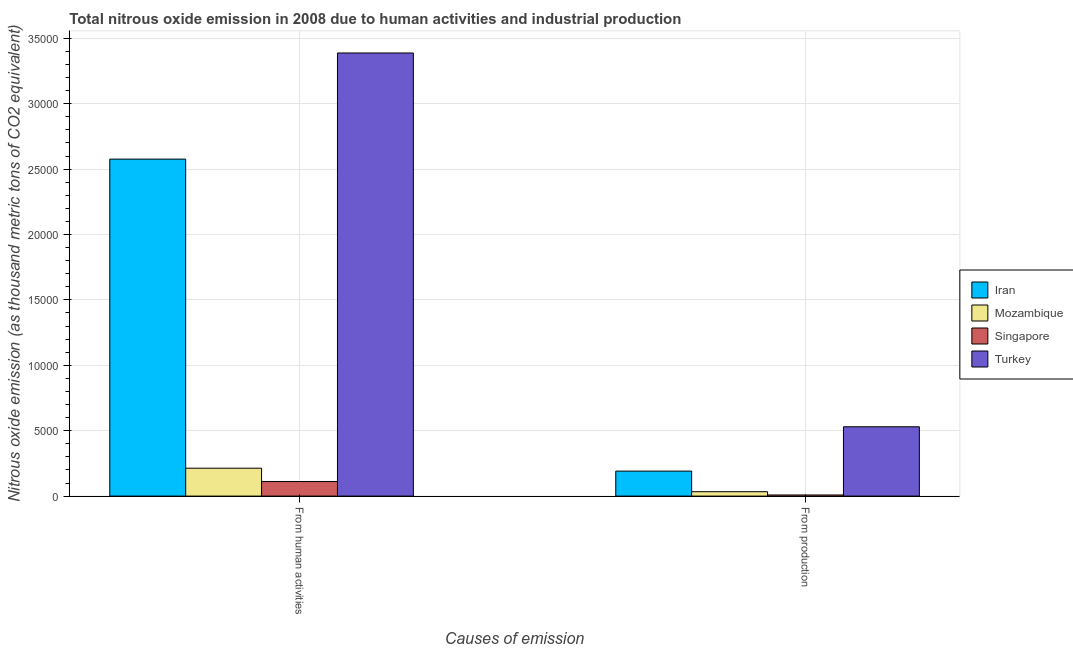How many groups of bars are there?
Your response must be concise. 2. Are the number of bars on each tick of the X-axis equal?
Ensure brevity in your answer.  Yes. How many bars are there on the 2nd tick from the left?
Offer a very short reply. 4. How many bars are there on the 2nd tick from the right?
Your answer should be very brief. 4. What is the label of the 1st group of bars from the left?
Offer a terse response. From human activities. What is the amount of emissions from human activities in Turkey?
Provide a short and direct response. 3.39e+04. Across all countries, what is the maximum amount of emissions generated from industries?
Give a very brief answer. 5300.3. Across all countries, what is the minimum amount of emissions from human activities?
Your response must be concise. 1113.5. In which country was the amount of emissions generated from industries maximum?
Ensure brevity in your answer.  Turkey. In which country was the amount of emissions from human activities minimum?
Offer a very short reply. Singapore. What is the total amount of emissions from human activities in the graph?
Make the answer very short. 6.29e+04. What is the difference between the amount of emissions from human activities in Singapore and that in Turkey?
Make the answer very short. -3.28e+04. What is the difference between the amount of emissions generated from industries in Turkey and the amount of emissions from human activities in Mozambique?
Ensure brevity in your answer.  3166.8. What is the average amount of emissions from human activities per country?
Offer a terse response. 1.57e+04. What is the difference between the amount of emissions generated from industries and amount of emissions from human activities in Singapore?
Your response must be concise. -1026.6. What is the ratio of the amount of emissions generated from industries in Mozambique to that in Iran?
Provide a short and direct response. 0.18. Is the amount of emissions generated from industries in Mozambique less than that in Singapore?
Your answer should be very brief. No. In how many countries, is the amount of emissions generated from industries greater than the average amount of emissions generated from industries taken over all countries?
Offer a terse response. 2. What does the 3rd bar from the left in From production represents?
Your response must be concise. Singapore. What does the 4th bar from the right in From human activities represents?
Your answer should be compact. Iran. How many bars are there?
Your answer should be compact. 8. Are the values on the major ticks of Y-axis written in scientific E-notation?
Keep it short and to the point. No. Does the graph contain any zero values?
Your answer should be very brief. No. What is the title of the graph?
Your response must be concise. Total nitrous oxide emission in 2008 due to human activities and industrial production. What is the label or title of the X-axis?
Give a very brief answer. Causes of emission. What is the label or title of the Y-axis?
Your answer should be very brief. Nitrous oxide emission (as thousand metric tons of CO2 equivalent). What is the Nitrous oxide emission (as thousand metric tons of CO2 equivalent) in Iran in From human activities?
Your answer should be very brief. 2.58e+04. What is the Nitrous oxide emission (as thousand metric tons of CO2 equivalent) in Mozambique in From human activities?
Provide a short and direct response. 2133.5. What is the Nitrous oxide emission (as thousand metric tons of CO2 equivalent) of Singapore in From human activities?
Your answer should be very brief. 1113.5. What is the Nitrous oxide emission (as thousand metric tons of CO2 equivalent) of Turkey in From human activities?
Your answer should be very brief. 3.39e+04. What is the Nitrous oxide emission (as thousand metric tons of CO2 equivalent) in Iran in From production?
Keep it short and to the point. 1911.5. What is the Nitrous oxide emission (as thousand metric tons of CO2 equivalent) in Mozambique in From production?
Keep it short and to the point. 336.3. What is the Nitrous oxide emission (as thousand metric tons of CO2 equivalent) in Singapore in From production?
Give a very brief answer. 86.9. What is the Nitrous oxide emission (as thousand metric tons of CO2 equivalent) of Turkey in From production?
Keep it short and to the point. 5300.3. Across all Causes of emission, what is the maximum Nitrous oxide emission (as thousand metric tons of CO2 equivalent) of Iran?
Keep it short and to the point. 2.58e+04. Across all Causes of emission, what is the maximum Nitrous oxide emission (as thousand metric tons of CO2 equivalent) in Mozambique?
Your answer should be compact. 2133.5. Across all Causes of emission, what is the maximum Nitrous oxide emission (as thousand metric tons of CO2 equivalent) of Singapore?
Keep it short and to the point. 1113.5. Across all Causes of emission, what is the maximum Nitrous oxide emission (as thousand metric tons of CO2 equivalent) in Turkey?
Your response must be concise. 3.39e+04. Across all Causes of emission, what is the minimum Nitrous oxide emission (as thousand metric tons of CO2 equivalent) of Iran?
Ensure brevity in your answer.  1911.5. Across all Causes of emission, what is the minimum Nitrous oxide emission (as thousand metric tons of CO2 equivalent) in Mozambique?
Your answer should be very brief. 336.3. Across all Causes of emission, what is the minimum Nitrous oxide emission (as thousand metric tons of CO2 equivalent) of Singapore?
Your answer should be compact. 86.9. Across all Causes of emission, what is the minimum Nitrous oxide emission (as thousand metric tons of CO2 equivalent) of Turkey?
Keep it short and to the point. 5300.3. What is the total Nitrous oxide emission (as thousand metric tons of CO2 equivalent) in Iran in the graph?
Make the answer very short. 2.77e+04. What is the total Nitrous oxide emission (as thousand metric tons of CO2 equivalent) of Mozambique in the graph?
Provide a short and direct response. 2469.8. What is the total Nitrous oxide emission (as thousand metric tons of CO2 equivalent) of Singapore in the graph?
Your response must be concise. 1200.4. What is the total Nitrous oxide emission (as thousand metric tons of CO2 equivalent) in Turkey in the graph?
Provide a succinct answer. 3.92e+04. What is the difference between the Nitrous oxide emission (as thousand metric tons of CO2 equivalent) in Iran in From human activities and that in From production?
Make the answer very short. 2.39e+04. What is the difference between the Nitrous oxide emission (as thousand metric tons of CO2 equivalent) in Mozambique in From human activities and that in From production?
Give a very brief answer. 1797.2. What is the difference between the Nitrous oxide emission (as thousand metric tons of CO2 equivalent) in Singapore in From human activities and that in From production?
Provide a short and direct response. 1026.6. What is the difference between the Nitrous oxide emission (as thousand metric tons of CO2 equivalent) of Turkey in From human activities and that in From production?
Provide a short and direct response. 2.86e+04. What is the difference between the Nitrous oxide emission (as thousand metric tons of CO2 equivalent) of Iran in From human activities and the Nitrous oxide emission (as thousand metric tons of CO2 equivalent) of Mozambique in From production?
Give a very brief answer. 2.54e+04. What is the difference between the Nitrous oxide emission (as thousand metric tons of CO2 equivalent) of Iran in From human activities and the Nitrous oxide emission (as thousand metric tons of CO2 equivalent) of Singapore in From production?
Keep it short and to the point. 2.57e+04. What is the difference between the Nitrous oxide emission (as thousand metric tons of CO2 equivalent) of Iran in From human activities and the Nitrous oxide emission (as thousand metric tons of CO2 equivalent) of Turkey in From production?
Your answer should be very brief. 2.05e+04. What is the difference between the Nitrous oxide emission (as thousand metric tons of CO2 equivalent) in Mozambique in From human activities and the Nitrous oxide emission (as thousand metric tons of CO2 equivalent) in Singapore in From production?
Keep it short and to the point. 2046.6. What is the difference between the Nitrous oxide emission (as thousand metric tons of CO2 equivalent) in Mozambique in From human activities and the Nitrous oxide emission (as thousand metric tons of CO2 equivalent) in Turkey in From production?
Provide a succinct answer. -3166.8. What is the difference between the Nitrous oxide emission (as thousand metric tons of CO2 equivalent) in Singapore in From human activities and the Nitrous oxide emission (as thousand metric tons of CO2 equivalent) in Turkey in From production?
Provide a short and direct response. -4186.8. What is the average Nitrous oxide emission (as thousand metric tons of CO2 equivalent) in Iran per Causes of emission?
Offer a terse response. 1.38e+04. What is the average Nitrous oxide emission (as thousand metric tons of CO2 equivalent) in Mozambique per Causes of emission?
Make the answer very short. 1234.9. What is the average Nitrous oxide emission (as thousand metric tons of CO2 equivalent) in Singapore per Causes of emission?
Keep it short and to the point. 600.2. What is the average Nitrous oxide emission (as thousand metric tons of CO2 equivalent) in Turkey per Causes of emission?
Ensure brevity in your answer.  1.96e+04. What is the difference between the Nitrous oxide emission (as thousand metric tons of CO2 equivalent) in Iran and Nitrous oxide emission (as thousand metric tons of CO2 equivalent) in Mozambique in From human activities?
Provide a short and direct response. 2.36e+04. What is the difference between the Nitrous oxide emission (as thousand metric tons of CO2 equivalent) of Iran and Nitrous oxide emission (as thousand metric tons of CO2 equivalent) of Singapore in From human activities?
Your response must be concise. 2.46e+04. What is the difference between the Nitrous oxide emission (as thousand metric tons of CO2 equivalent) of Iran and Nitrous oxide emission (as thousand metric tons of CO2 equivalent) of Turkey in From human activities?
Keep it short and to the point. -8114.9. What is the difference between the Nitrous oxide emission (as thousand metric tons of CO2 equivalent) in Mozambique and Nitrous oxide emission (as thousand metric tons of CO2 equivalent) in Singapore in From human activities?
Your answer should be very brief. 1020. What is the difference between the Nitrous oxide emission (as thousand metric tons of CO2 equivalent) in Mozambique and Nitrous oxide emission (as thousand metric tons of CO2 equivalent) in Turkey in From human activities?
Your response must be concise. -3.17e+04. What is the difference between the Nitrous oxide emission (as thousand metric tons of CO2 equivalent) of Singapore and Nitrous oxide emission (as thousand metric tons of CO2 equivalent) of Turkey in From human activities?
Keep it short and to the point. -3.28e+04. What is the difference between the Nitrous oxide emission (as thousand metric tons of CO2 equivalent) of Iran and Nitrous oxide emission (as thousand metric tons of CO2 equivalent) of Mozambique in From production?
Give a very brief answer. 1575.2. What is the difference between the Nitrous oxide emission (as thousand metric tons of CO2 equivalent) of Iran and Nitrous oxide emission (as thousand metric tons of CO2 equivalent) of Singapore in From production?
Provide a short and direct response. 1824.6. What is the difference between the Nitrous oxide emission (as thousand metric tons of CO2 equivalent) in Iran and Nitrous oxide emission (as thousand metric tons of CO2 equivalent) in Turkey in From production?
Keep it short and to the point. -3388.8. What is the difference between the Nitrous oxide emission (as thousand metric tons of CO2 equivalent) of Mozambique and Nitrous oxide emission (as thousand metric tons of CO2 equivalent) of Singapore in From production?
Ensure brevity in your answer.  249.4. What is the difference between the Nitrous oxide emission (as thousand metric tons of CO2 equivalent) in Mozambique and Nitrous oxide emission (as thousand metric tons of CO2 equivalent) in Turkey in From production?
Keep it short and to the point. -4964. What is the difference between the Nitrous oxide emission (as thousand metric tons of CO2 equivalent) of Singapore and Nitrous oxide emission (as thousand metric tons of CO2 equivalent) of Turkey in From production?
Your answer should be compact. -5213.4. What is the ratio of the Nitrous oxide emission (as thousand metric tons of CO2 equivalent) of Iran in From human activities to that in From production?
Ensure brevity in your answer.  13.48. What is the ratio of the Nitrous oxide emission (as thousand metric tons of CO2 equivalent) of Mozambique in From human activities to that in From production?
Give a very brief answer. 6.34. What is the ratio of the Nitrous oxide emission (as thousand metric tons of CO2 equivalent) of Singapore in From human activities to that in From production?
Give a very brief answer. 12.81. What is the ratio of the Nitrous oxide emission (as thousand metric tons of CO2 equivalent) in Turkey in From human activities to that in From production?
Provide a short and direct response. 6.39. What is the difference between the highest and the second highest Nitrous oxide emission (as thousand metric tons of CO2 equivalent) in Iran?
Ensure brevity in your answer.  2.39e+04. What is the difference between the highest and the second highest Nitrous oxide emission (as thousand metric tons of CO2 equivalent) of Mozambique?
Your answer should be very brief. 1797.2. What is the difference between the highest and the second highest Nitrous oxide emission (as thousand metric tons of CO2 equivalent) in Singapore?
Give a very brief answer. 1026.6. What is the difference between the highest and the second highest Nitrous oxide emission (as thousand metric tons of CO2 equivalent) of Turkey?
Provide a short and direct response. 2.86e+04. What is the difference between the highest and the lowest Nitrous oxide emission (as thousand metric tons of CO2 equivalent) in Iran?
Make the answer very short. 2.39e+04. What is the difference between the highest and the lowest Nitrous oxide emission (as thousand metric tons of CO2 equivalent) of Mozambique?
Your answer should be very brief. 1797.2. What is the difference between the highest and the lowest Nitrous oxide emission (as thousand metric tons of CO2 equivalent) of Singapore?
Provide a short and direct response. 1026.6. What is the difference between the highest and the lowest Nitrous oxide emission (as thousand metric tons of CO2 equivalent) of Turkey?
Your response must be concise. 2.86e+04. 